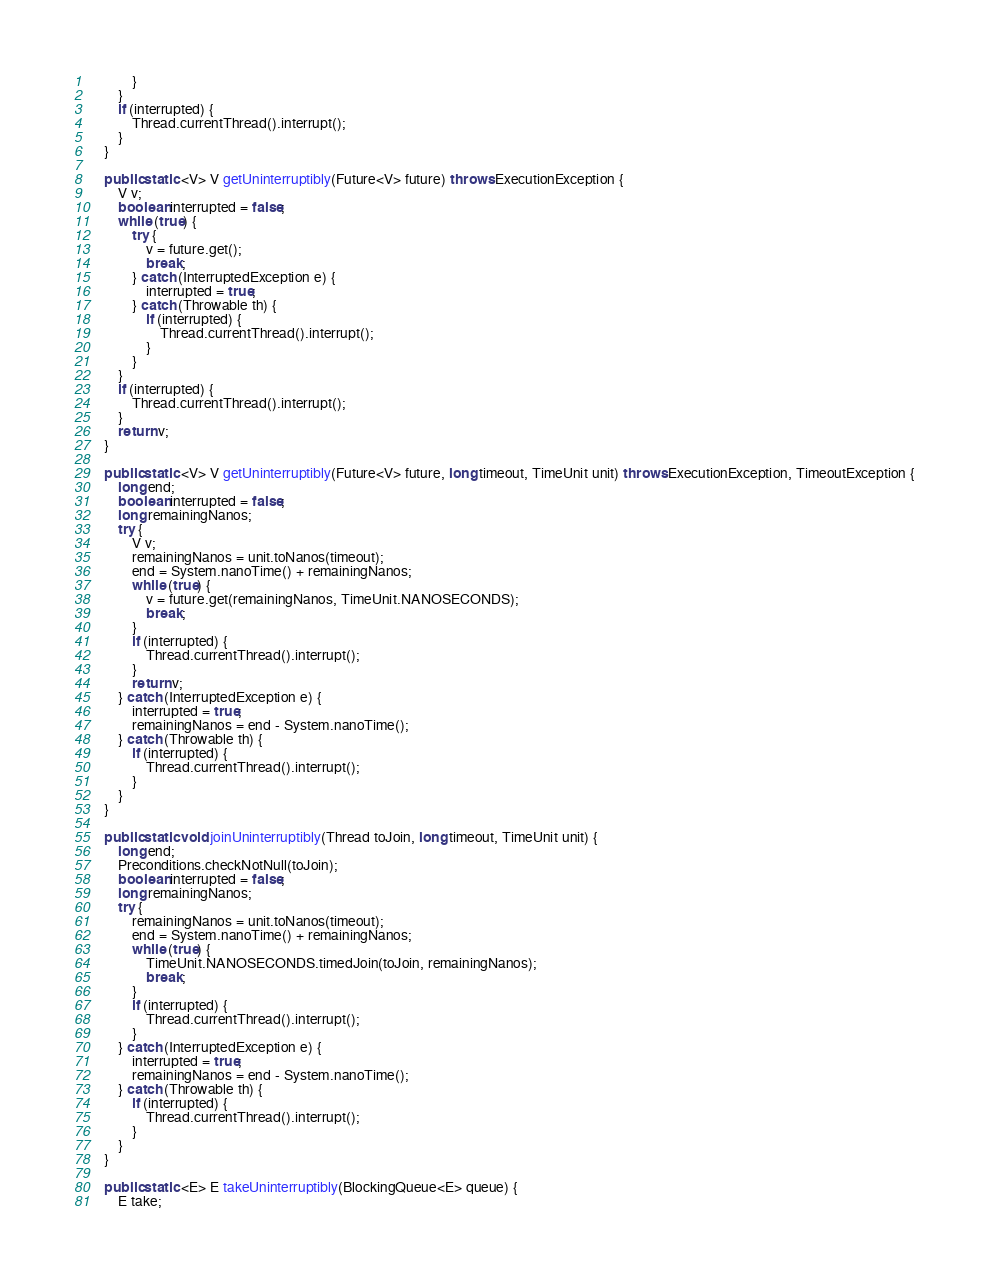Convert code to text. <code><loc_0><loc_0><loc_500><loc_500><_Java_>            }
        }
        if (interrupted) {
            Thread.currentThread().interrupt();
        }
    }

    public static <V> V getUninterruptibly(Future<V> future) throws ExecutionException {
        V v;
        boolean interrupted = false;
        while (true) {
            try {
                v = future.get();
                break;
            } catch (InterruptedException e) {
                interrupted = true;
            } catch (Throwable th) {
                if (interrupted) {
                    Thread.currentThread().interrupt();
                }
            }
        }
        if (interrupted) {
            Thread.currentThread().interrupt();
        }
        return v;
    }

    public static <V> V getUninterruptibly(Future<V> future, long timeout, TimeUnit unit) throws ExecutionException, TimeoutException {
        long end;
        boolean interrupted = false;
        long remainingNanos;
        try {
            V v;
            remainingNanos = unit.toNanos(timeout);
            end = System.nanoTime() + remainingNanos;
            while (true) {
                v = future.get(remainingNanos, TimeUnit.NANOSECONDS);
                break;
            }
            if (interrupted) {
                Thread.currentThread().interrupt();
            }
            return v;
        } catch (InterruptedException e) {
            interrupted = true;
            remainingNanos = end - System.nanoTime();
        } catch (Throwable th) {
            if (interrupted) {
                Thread.currentThread().interrupt();
            }
        }
    }

    public static void joinUninterruptibly(Thread toJoin, long timeout, TimeUnit unit) {
        long end;
        Preconditions.checkNotNull(toJoin);
        boolean interrupted = false;
        long remainingNanos;
        try {
            remainingNanos = unit.toNanos(timeout);
            end = System.nanoTime() + remainingNanos;
            while (true) {
                TimeUnit.NANOSECONDS.timedJoin(toJoin, remainingNanos);
                break;
            }
            if (interrupted) {
                Thread.currentThread().interrupt();
            }
        } catch (InterruptedException e) {
            interrupted = true;
            remainingNanos = end - System.nanoTime();
        } catch (Throwable th) {
            if (interrupted) {
                Thread.currentThread().interrupt();
            }
        }
    }

    public static <E> E takeUninterruptibly(BlockingQueue<E> queue) {
        E take;</code> 